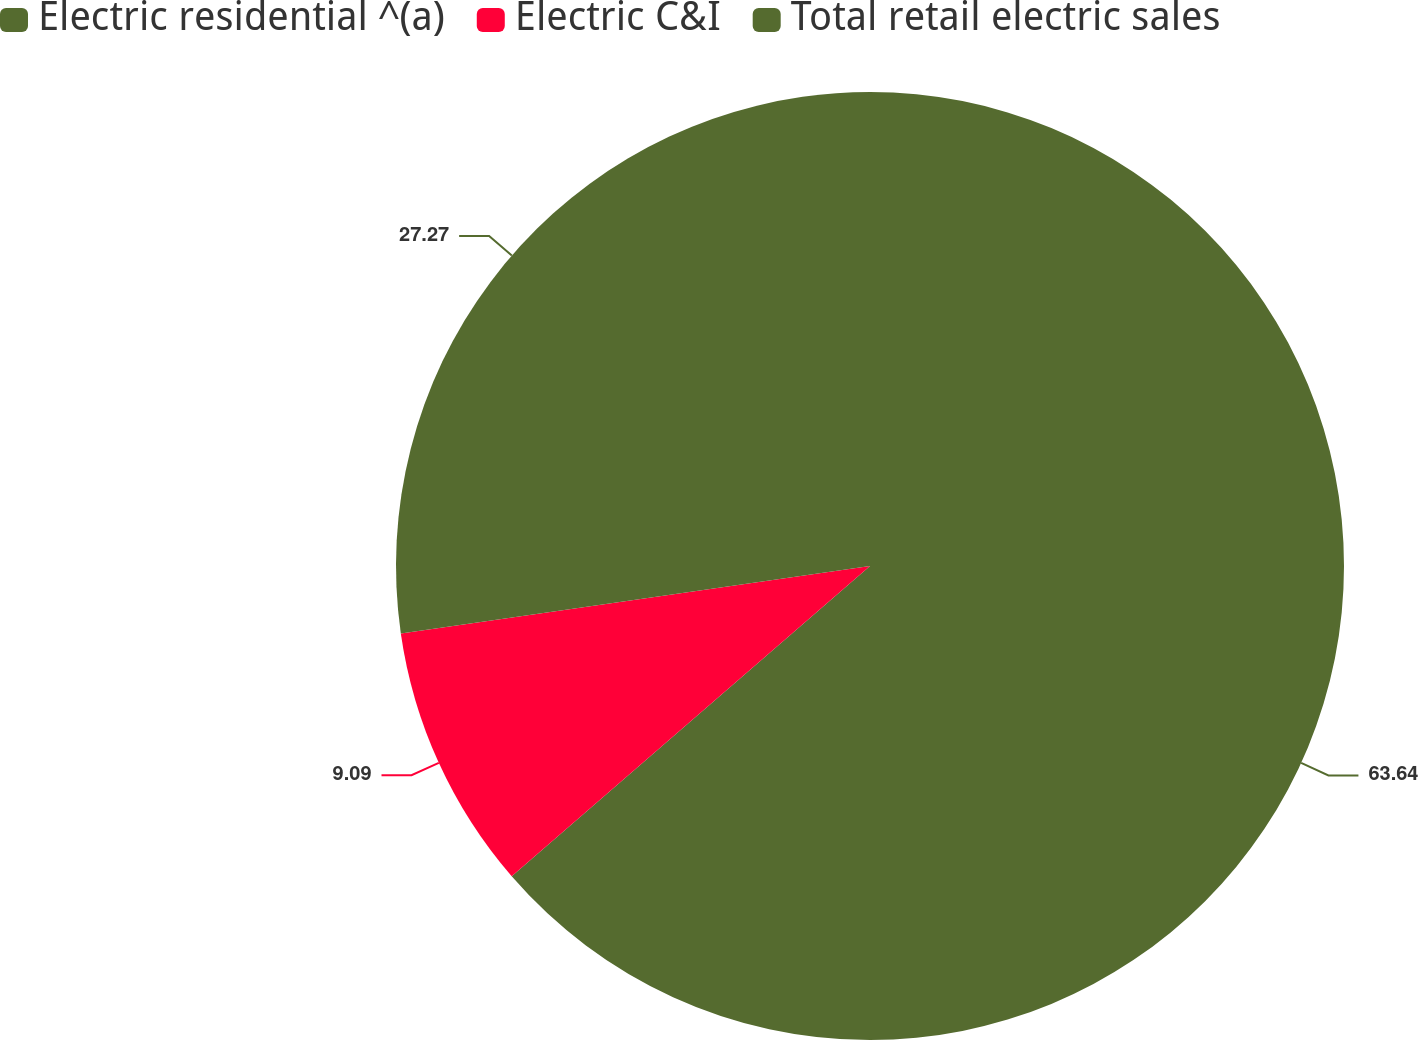<chart> <loc_0><loc_0><loc_500><loc_500><pie_chart><fcel>Electric residential ^(a)<fcel>Electric C&I<fcel>Total retail electric sales<nl><fcel>63.64%<fcel>9.09%<fcel>27.27%<nl></chart> 